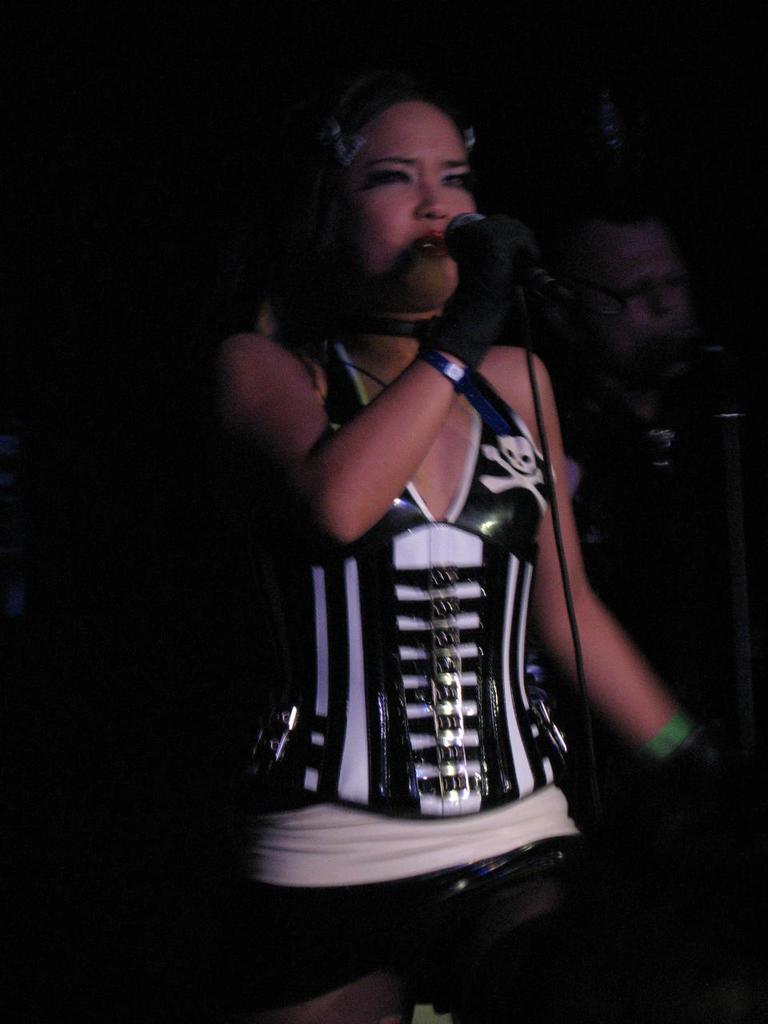Describe this image in one or two sentences. Where we can see lady standing with microphone in her hand singing, behind her there is a man who is also singing in the microphone 